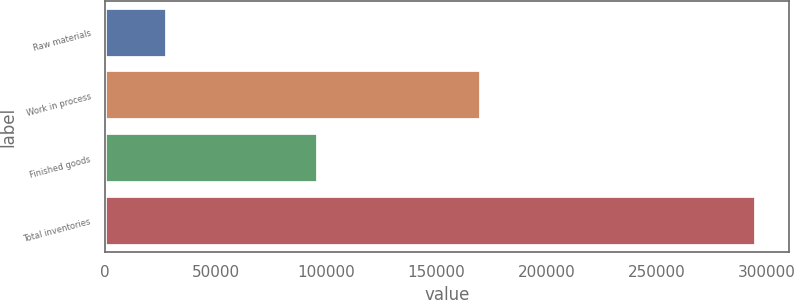Convert chart to OTSL. <chart><loc_0><loc_0><loc_500><loc_500><bar_chart><fcel>Raw materials<fcel>Work in process<fcel>Finished goods<fcel>Total inventories<nl><fcel>28085<fcel>170398<fcel>96598<fcel>295081<nl></chart> 